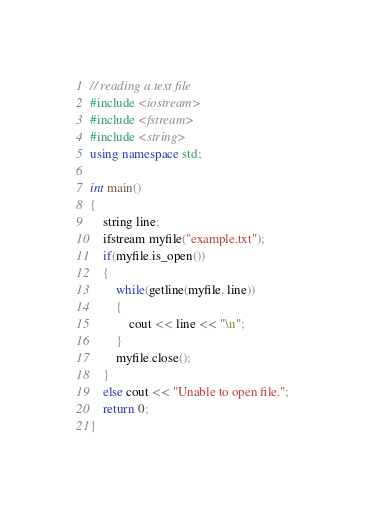Convert code to text. <code><loc_0><loc_0><loc_500><loc_500><_C++_>// reading a text file
#include <iostream>
#include <fstream>
#include <string>
using namespace std;

int main()
{
    string line;
    ifstream myfile("example.txt");
    if(myfile.is_open())
    {
        while(getline(myfile, line))
        {
            cout << line << "\n";
        }
        myfile.close();
    }
    else cout << "Unable to open file.";
    return 0;
}
</code> 